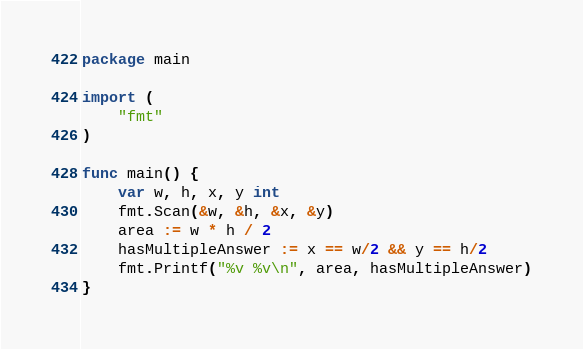Convert code to text. <code><loc_0><loc_0><loc_500><loc_500><_Go_>package main

import (
	"fmt"
)

func main() {
	var w, h, x, y int
	fmt.Scan(&w, &h, &x, &y)
	area := w * h / 2
	hasMultipleAnswer := x == w/2 && y == h/2
	fmt.Printf("%v %v\n", area, hasMultipleAnswer)
}
</code> 